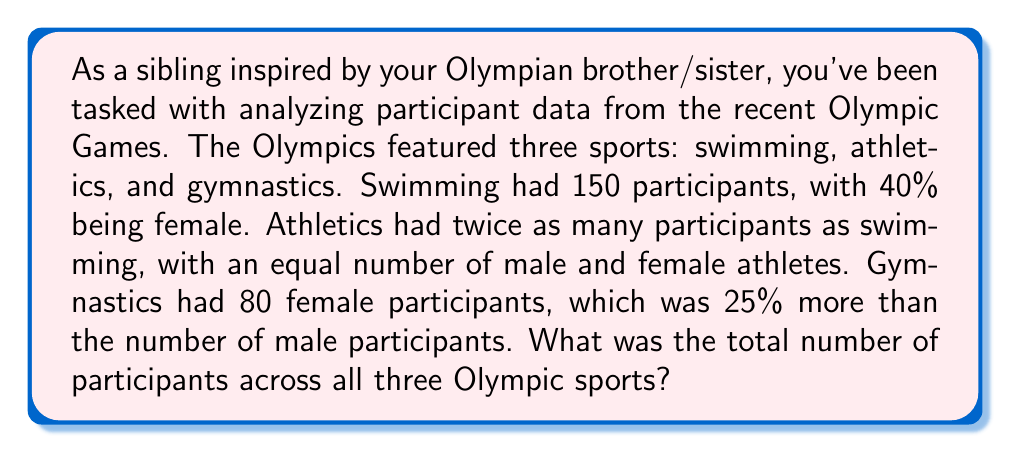Teach me how to tackle this problem. Let's break this down step by step:

1) Swimming:
   - Total participants: 150
   - Female participants: $150 \times 40\% = 150 \times 0.4 = 60$
   - Male participants: $150 - 60 = 90$

2) Athletics:
   - Total participants: $150 \times 2 = 300$ (twice as many as swimming)
   - Female participants: $300 \div 2 = 150$ (equal number of male and female)
   - Male participants: 150

3) Gymnastics:
   - Female participants: 80
   - Male participants: Let $x$ be the number of male participants
     $80 = x + 25\% \text{ of } x = x + 0.25x = 1.25x$
     $x = 80 \div 1.25 = 64$
   - Total participants: $80 + 64 = 144$

4) Total participants across all sports:
   $$150 + 300 + 144 = 594$$
Answer: 594 participants 